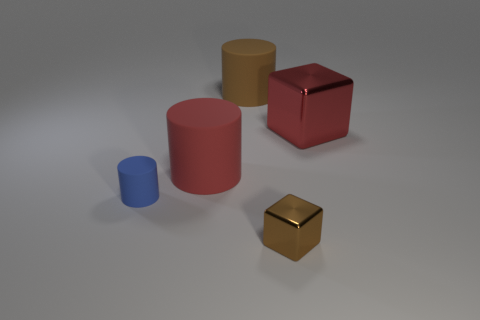Can you describe the lighting in the scene? The lighting in the scene appears to come from the left-hand side, casting soft shadows to the right of the objects. It creates highlights on the edges closer to the light source and gives the scene a calm and balanced atmosphere. 